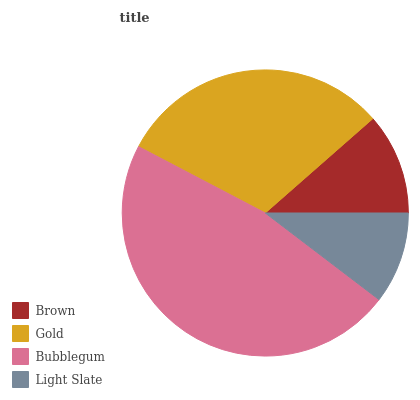Is Light Slate the minimum?
Answer yes or no. Yes. Is Bubblegum the maximum?
Answer yes or no. Yes. Is Gold the minimum?
Answer yes or no. No. Is Gold the maximum?
Answer yes or no. No. Is Gold greater than Brown?
Answer yes or no. Yes. Is Brown less than Gold?
Answer yes or no. Yes. Is Brown greater than Gold?
Answer yes or no. No. Is Gold less than Brown?
Answer yes or no. No. Is Gold the high median?
Answer yes or no. Yes. Is Brown the low median?
Answer yes or no. Yes. Is Bubblegum the high median?
Answer yes or no. No. Is Gold the low median?
Answer yes or no. No. 